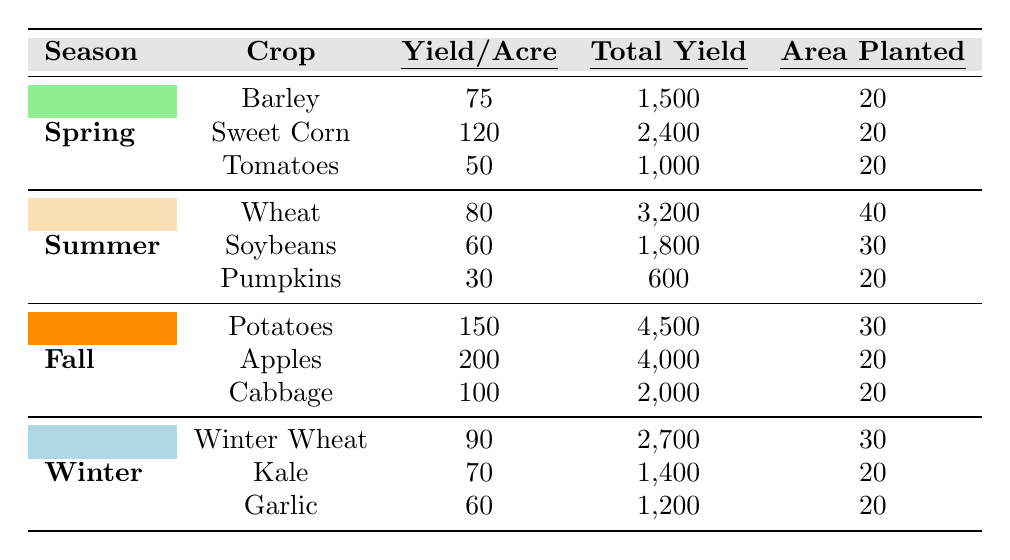What crop had the highest yield per acre in Spring? The table shows that Sweet Corn has the highest yield per acre at 120. We find this by comparing the yield per acre values for Barley (75), Sweet Corn (120), and Tomatoes (50).
Answer: Sweet Corn What is the total yield of Apples in Fall? The total yield for Apples is directly stated in the Fall section, which is 4,000. There is no calculation needed here as the value is explicitly provided.
Answer: 4,000 Which crop was planted in the largest area in Summer? The area planted for Wheat is 40 acres, which is the largest compared to Soybeans (30 acres) and Pumpkins (20 acres). This is determined by checking the area planted values in the Summer section.
Answer: Wheat What is the average yield per acre for all crops in Winter? The yields per acre for Winter crops are 90 (Winter Wheat), 70 (Kale), and 60 (Garlic). Summing them gives 90 + 70 + 60 = 220. Dividing by 3 (the number of crops) results in an average of 220 / 3 = about 73.33.
Answer: 73.33 True or False: The total yield for Potatoes is greater than the total yield for Garlic. The total yield for Potatoes is 4,500 while for Garlic it is 1,200. Since 4,500 is indeed greater than 1,200, the statement is true.
Answer: True What is the total area planted for all crops in Spring? The total area planted in Spring is calculated by adding the individual areas planted for each crop: Barley (20) + Sweet Corn (20) + Tomatoes (20) = 60 acres.
Answer: 60 Which season produced the highest total yield among all crops? To determine this, we compare total yields across seasons: Spring (4,900), Summer (4,600), Fall (10,500), and Winter (4,300). Fall has the highest total yield with 10,500.
Answer: Fall What is the difference between total yields of Winter Wheat and Pumpkins? The total yield for Winter Wheat is 2,700 and for Pumpkins, it is 600. The difference is calculated as 2,700 - 600 = 2,100.
Answer: 2,100 What is the total yield for all crops in Summer? The total yield in Summer is found by adding Wheat (3,200), Soybeans (1,800), and Pumpkins (600): 3,200 + 1,800 + 600 = 5,600. Thus, the total yield for Summer crops is 5,600.
Answer: 5,600 Does Kale yield more per acre than Tomatoes? Kale's yield per acre is 70 and Tomatoes yield 50. Since 70 is greater than 50, the statement is true.
Answer: True 